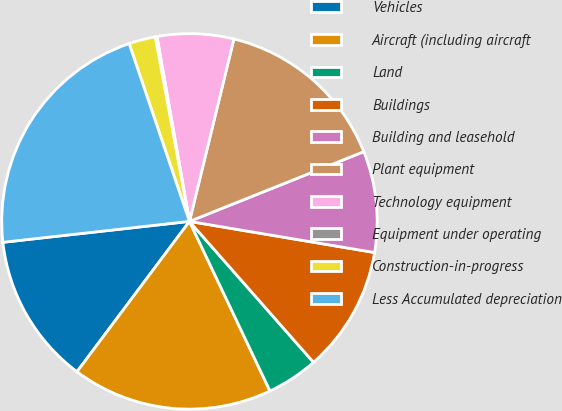Convert chart to OTSL. <chart><loc_0><loc_0><loc_500><loc_500><pie_chart><fcel>Vehicles<fcel>Aircraft (including aircraft<fcel>Land<fcel>Buildings<fcel>Building and leasehold<fcel>Plant equipment<fcel>Technology equipment<fcel>Equipment under operating<fcel>Construction-in-progress<fcel>Less Accumulated depreciation<nl><fcel>13.0%<fcel>17.28%<fcel>4.43%<fcel>10.86%<fcel>8.71%<fcel>15.14%<fcel>6.57%<fcel>0.15%<fcel>2.29%<fcel>21.57%<nl></chart> 